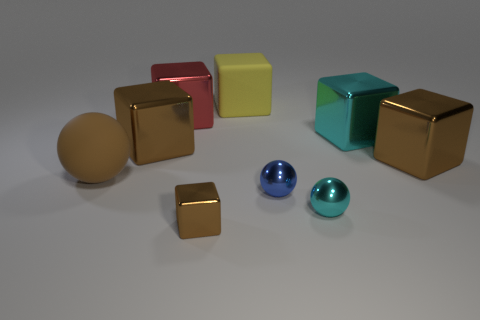What is the arrangement of the objects? The objects are arranged somewhat randomly on a flat surface. There is no apparent pattern to their placement, but there is a mix of geometric shapes including cubes and spheres creating a visually balanced composition. 